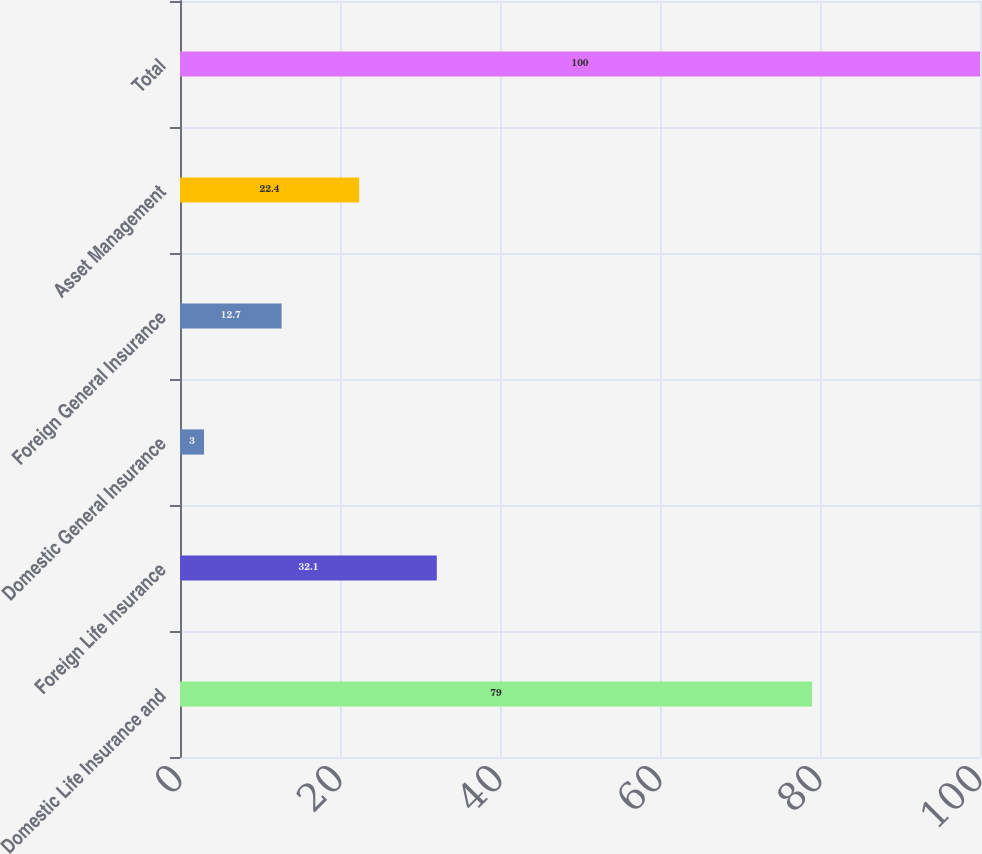<chart> <loc_0><loc_0><loc_500><loc_500><bar_chart><fcel>Domestic Life Insurance and<fcel>Foreign Life Insurance<fcel>Domestic General Insurance<fcel>Foreign General Insurance<fcel>Asset Management<fcel>Total<nl><fcel>79<fcel>32.1<fcel>3<fcel>12.7<fcel>22.4<fcel>100<nl></chart> 